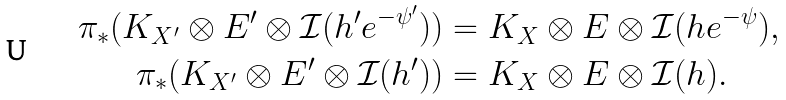Convert formula to latex. <formula><loc_0><loc_0><loc_500><loc_500>\pi _ { * } ( K _ { X ^ { \prime } } \otimes E ^ { \prime } \otimes \mathcal { I } ( h ^ { \prime } e ^ { - \psi ^ { \prime } } ) ) & = K _ { X } \otimes E \otimes \mathcal { I } ( h e ^ { - \psi } ) , \\ \pi _ { * } ( K _ { X ^ { \prime } } \otimes E ^ { \prime } \otimes \mathcal { I } ( h ^ { \prime } ) ) & = K _ { X } \otimes E \otimes \mathcal { I } ( h ) .</formula> 